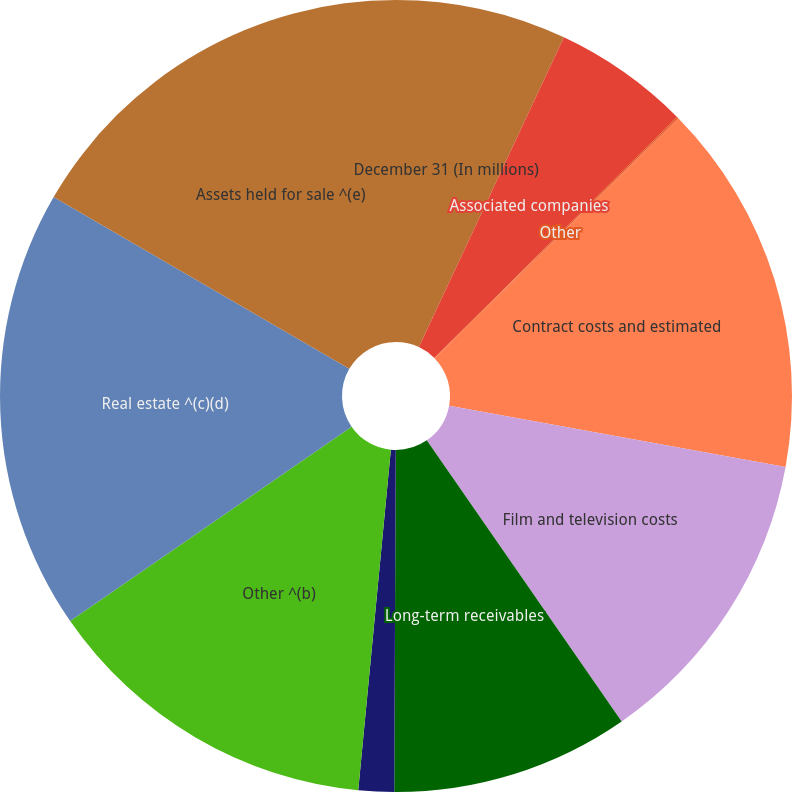<chart> <loc_0><loc_0><loc_500><loc_500><pie_chart><fcel>December 31 (In millions)<fcel>Associated companies<fcel>Other<fcel>Contract costs and estimated<fcel>Film and television costs<fcel>Long-term receivables<fcel>Derivative instruments<fcel>Other ^(b)<fcel>Real estate ^(c)(d)<fcel>Assets held for sale ^(e)<nl><fcel>6.97%<fcel>5.59%<fcel>0.07%<fcel>15.24%<fcel>12.48%<fcel>9.72%<fcel>1.45%<fcel>13.86%<fcel>18.0%<fcel>16.62%<nl></chart> 